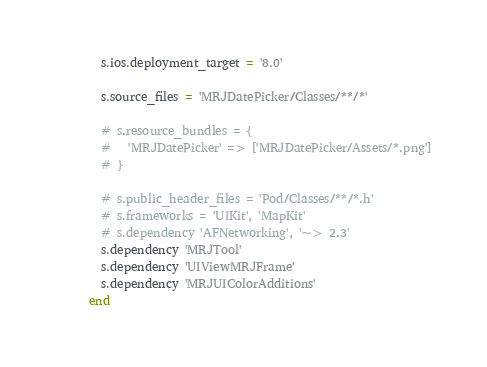Convert code to text. <code><loc_0><loc_0><loc_500><loc_500><_Ruby_>  s.ios.deployment_target = '8.0'

  s.source_files = 'MRJDatePicker/Classes/**/*'
  
  # s.resource_bundles = {
  #   'MRJDatePicker' => ['MRJDatePicker/Assets/*.png']
  # }

  # s.public_header_files = 'Pod/Classes/**/*.h'
  # s.frameworks = 'UIKit', 'MapKit'
  # s.dependency 'AFNetworking', '~> 2.3'
  s.dependency 'MRJTool'
  s.dependency 'UIViewMRJFrame'
  s.dependency 'MRJUIColorAdditions'
end
</code> 